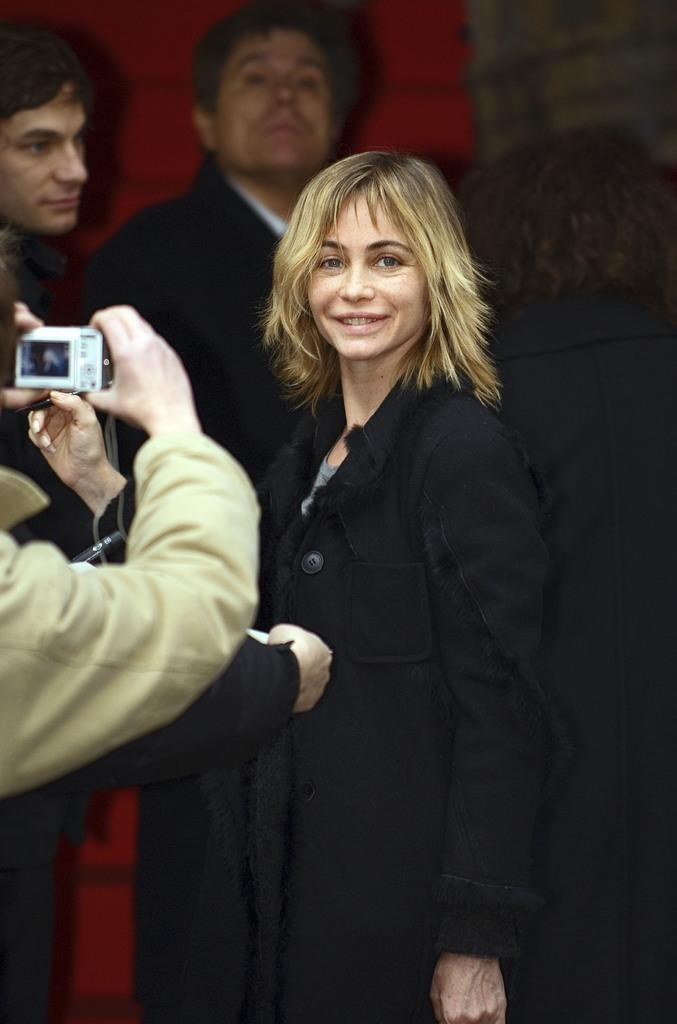How many people are in the image? There are people in the image, but the exact number is not specified. What is one person on the left side doing? One person on the left side is holding a camera. Who is wearing a crown in the image? There is no mention of a crown or any person wearing one in the image. 